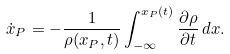Convert formula to latex. <formula><loc_0><loc_0><loc_500><loc_500>\dot { x } _ { P } = - \frac { 1 } { \rho ( x _ { P } , t ) } \int _ { - \infty } ^ { x _ { P } ( t ) } \frac { \partial \rho } { \partial t } \, d x .</formula> 